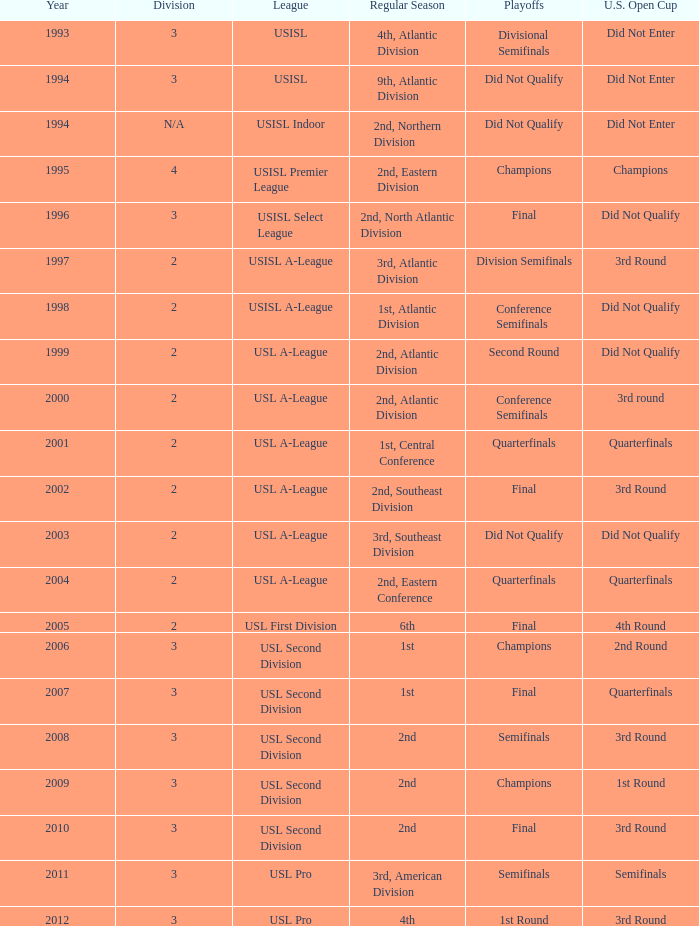In which round does the u.s. open cup division semi-finals occur? 3rd Round. Could you help me parse every detail presented in this table? {'header': ['Year', 'Division', 'League', 'Regular Season', 'Playoffs', 'U.S. Open Cup'], 'rows': [['1993', '3', 'USISL', '4th, Atlantic Division', 'Divisional Semifinals', 'Did Not Enter'], ['1994', '3', 'USISL', '9th, Atlantic Division', 'Did Not Qualify', 'Did Not Enter'], ['1994', 'N/A', 'USISL Indoor', '2nd, Northern Division', 'Did Not Qualify', 'Did Not Enter'], ['1995', '4', 'USISL Premier League', '2nd, Eastern Division', 'Champions', 'Champions'], ['1996', '3', 'USISL Select League', '2nd, North Atlantic Division', 'Final', 'Did Not Qualify'], ['1997', '2', 'USISL A-League', '3rd, Atlantic Division', 'Division Semifinals', '3rd Round'], ['1998', '2', 'USISL A-League', '1st, Atlantic Division', 'Conference Semifinals', 'Did Not Qualify'], ['1999', '2', 'USL A-League', '2nd, Atlantic Division', 'Second Round', 'Did Not Qualify'], ['2000', '2', 'USL A-League', '2nd, Atlantic Division', 'Conference Semifinals', '3rd round'], ['2001', '2', 'USL A-League', '1st, Central Conference', 'Quarterfinals', 'Quarterfinals'], ['2002', '2', 'USL A-League', '2nd, Southeast Division', 'Final', '3rd Round'], ['2003', '2', 'USL A-League', '3rd, Southeast Division', 'Did Not Qualify', 'Did Not Qualify'], ['2004', '2', 'USL A-League', '2nd, Eastern Conference', 'Quarterfinals', 'Quarterfinals'], ['2005', '2', 'USL First Division', '6th', 'Final', '4th Round'], ['2006', '3', 'USL Second Division', '1st', 'Champions', '2nd Round'], ['2007', '3', 'USL Second Division', '1st', 'Final', 'Quarterfinals'], ['2008', '3', 'USL Second Division', '2nd', 'Semifinals', '3rd Round'], ['2009', '3', 'USL Second Division', '2nd', 'Champions', '1st Round'], ['2010', '3', 'USL Second Division', '2nd', 'Final', '3rd Round'], ['2011', '3', 'USL Pro', '3rd, American Division', 'Semifinals', 'Semifinals'], ['2012', '3', 'USL Pro', '4th', '1st Round', '3rd Round']]} 